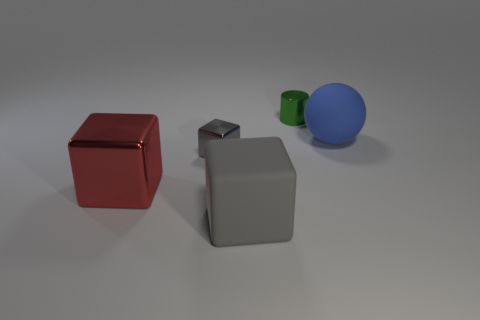Add 4 big blue matte balls. How many objects exist? 9 Subtract all spheres. How many objects are left? 4 Subtract 0 yellow spheres. How many objects are left? 5 Subtract all blue things. Subtract all big blue matte balls. How many objects are left? 3 Add 3 big blocks. How many big blocks are left? 5 Add 3 gray objects. How many gray objects exist? 5 